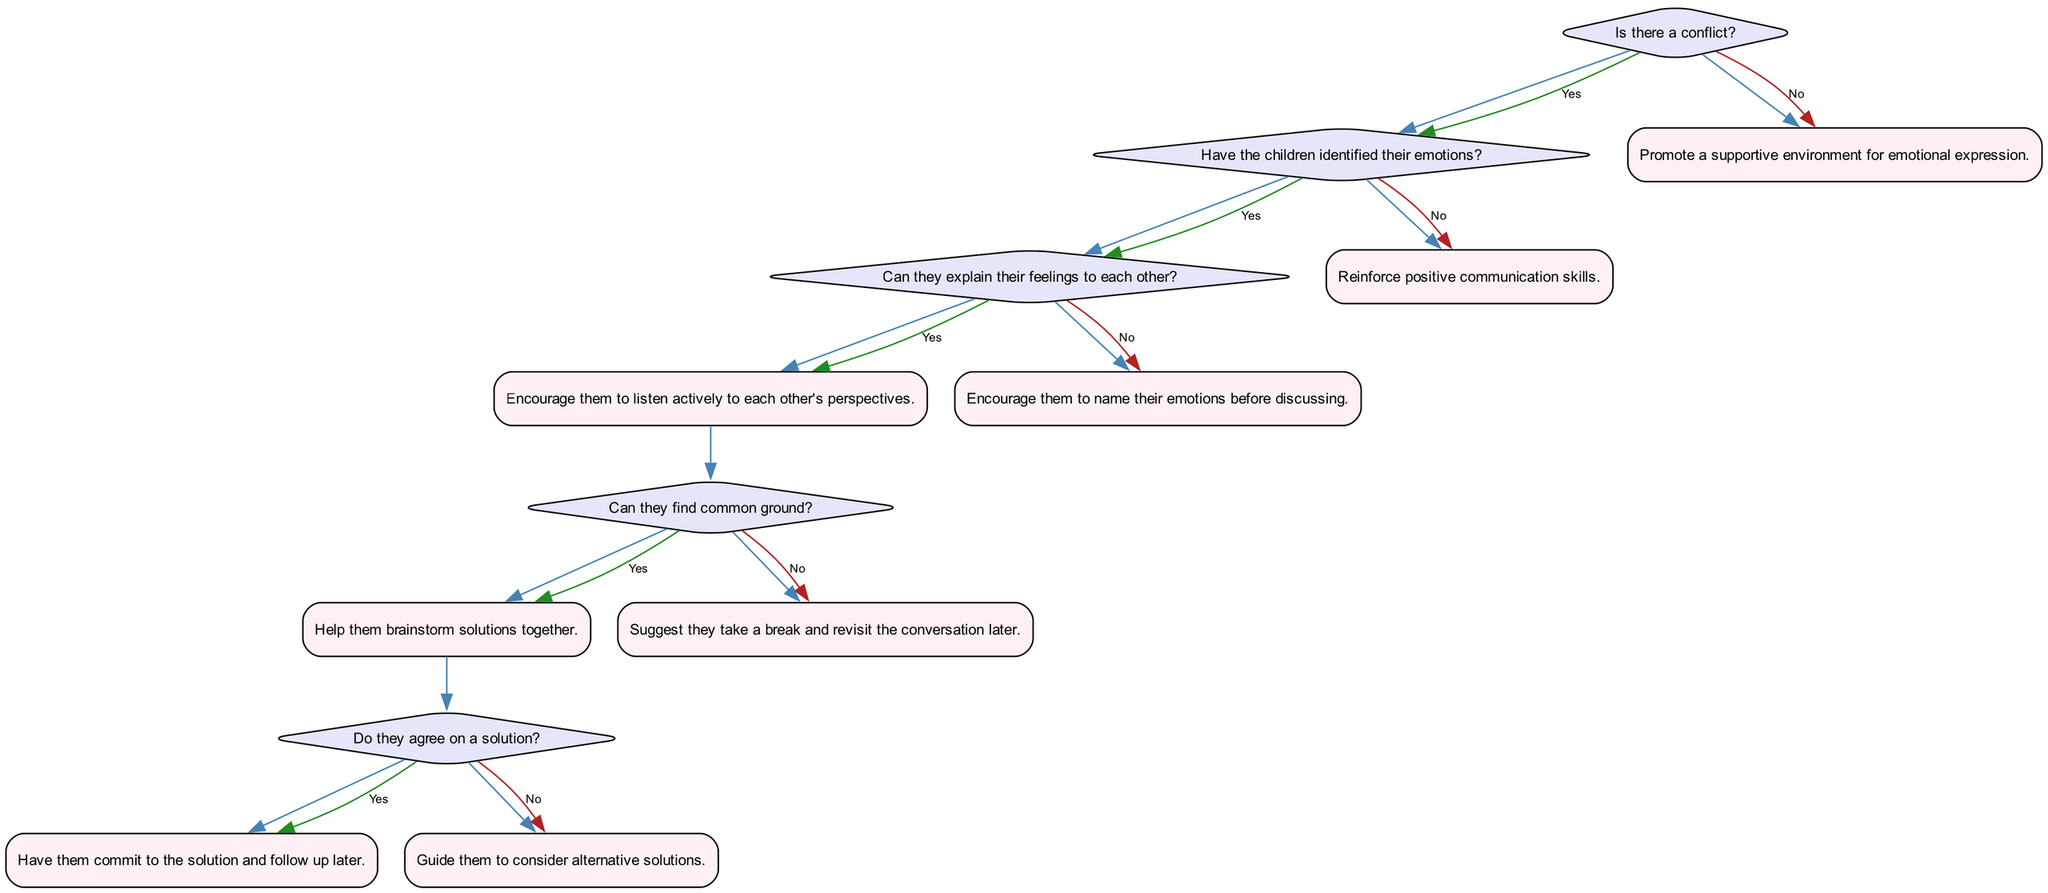What is the first question in the decision tree? The first question in the decision tree is "Is there a conflict?" This is the starting point of the flowchart that sets the stage for the entire decision-making process regarding conflict resolution.
Answer: Is there a conflict? How many possible actions are there if there is a conflict? If there is a conflict, there are four possible actions based on the various branches stemming from the initial question. These actions encompass guiding children through their emotions and the resolution process depending on their responses.
Answer: Four What happens if the children have not identified their emotions? If the children have not identified their emotions, the action to take is to "Encourage them to name their emotions before discussing." This is a crucial step before any dialogue can take place regarding the conflict.
Answer: Encourage them to name their emotions before discussing What is the final action if the children do not agree on a solution? If the children do not agree on a solution, the final action is to "Guide them to consider alternative solutions." This helps facilitate further exploration of options, ensuring a productive resolution.
Answer: Guide them to consider alternative solutions Which node indicates that the children should take a break? The node that indicates the children should take a break is connected to the question "Can they find common ground?" If they answer "no" to this question, the action is to "Suggest they take a break and revisit the conversation later." This provides a valuable cooling-off period.
Answer: Suggest they take a break and revisit the conversation later What are the outcomes if the answer to "Can they find common ground?" is yes? If the answer to "Can they find common ground?" is yes, the next action is "Help them brainstorm solutions together." This step is crucial for collaborative problem-solving and fosters teamwork.
Answer: Help them brainstorm solutions together How many total questions are in the decision tree? There are six questions in the decision tree, each leading to various potential paths and outcomes regarding the conflict resolution process.
Answer: Six 